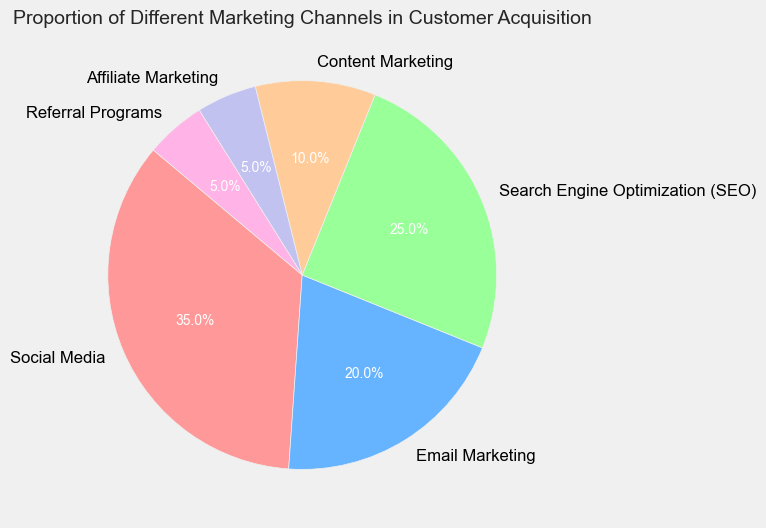Which marketing channel has the highest proportion? Looking at the pie chart, Social Media has the largest slice, which indicates it has the highest proportion.
Answer: Social Media Compare the proportion of Email Marketing and Content Marketing. Which one has a higher proportion? By comparing the sizes of the slices for Email Marketing and Content Marketing, it is clear that Email Marketing’s slice is larger.
Answer: Email Marketing What is the combined proportion of Social Media and SEO channels? Social Media accounts for 35% and SEO for 25%. Adding these proportions together results in a combined proportion of 35 + 25 = 60%.
Answer: 60% Which marketing channels each constitute less than 10% of the total? By examining the pie chart, the slices for Affiliate Marketing and Referral Programs are the smallest and represent less than 10% each. Affiliate Marketing and Referral Programs are both 5%.
Answer: Affiliate Marketing, Referral Programs What is the difference in proportion between the largest and the smallest marketing channel? The largest marketing channel is Social Media with 35%, and the smallest is Affiliate Marketing and Referral Programs each with 5%. The difference is 35 - 5 = 30%.
Answer: 30% What is the average proportion of all marketing channels? To find the average, add all the proportions and divide by the number of channels. The sum of proportions is 35 + 20 + 25 + 10 + 5 + 5 = 100. There are 6 channels. So, the average is 100 / 6 ≈ 16.67%.
Answer: 16.67% Which marketing channel has a proportion that is exactly twice the proportion of Affiliate Marketing? Affiliate Marketing has a proportion of 5%. The channel with a proportion twice that of Affiliate Marketing is Email Marketing, which has 10%.
Answer: Content Marketing How much more is the proportion of SEO compared to the proportion of Content Marketing? SEO has a proportion of 25%, and Content Marketing has 10%. The difference is 25 - 10 = 15%.
Answer: 15% Which three marketing channels together make up more than 50% of the total proportion? By summing up the three largest proportions: Social Media (35%), SEO (25%), and Email Marketing (20%), we get 35 + 25 + 20 = 80%, which is more than 50%.
Answer: Social Media, SEO, Email Marketing 